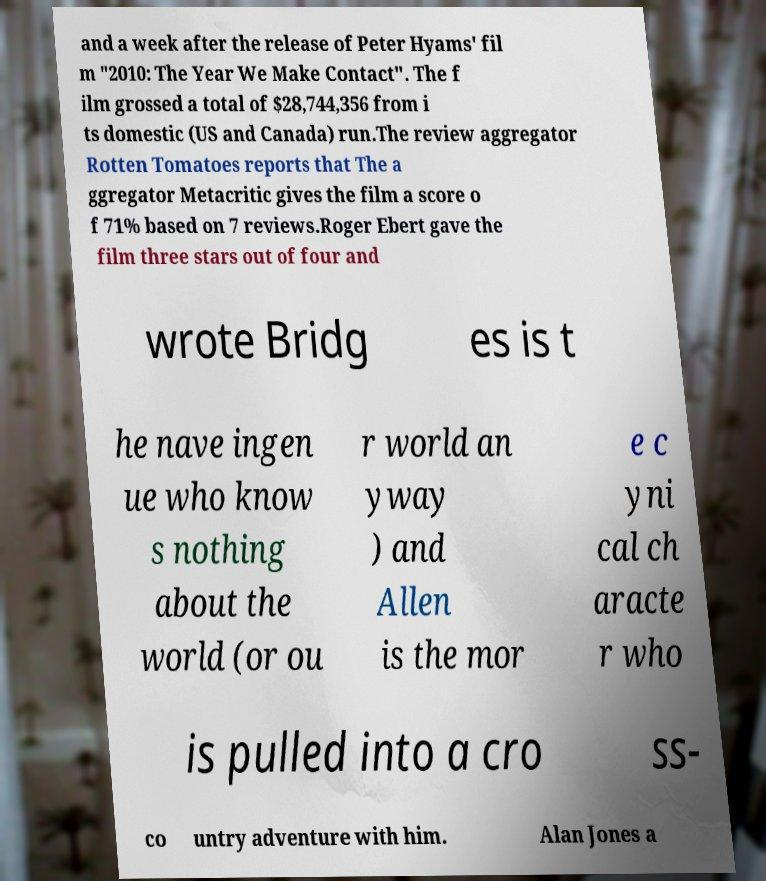What messages or text are displayed in this image? I need them in a readable, typed format. and a week after the release of Peter Hyams' fil m "2010: The Year We Make Contact". The f ilm grossed a total of $28,744,356 from i ts domestic (US and Canada) run.The review aggregator Rotten Tomatoes reports that The a ggregator Metacritic gives the film a score o f 71% based on 7 reviews.Roger Ebert gave the film three stars out of four and wrote Bridg es is t he nave ingen ue who know s nothing about the world (or ou r world an yway ) and Allen is the mor e c yni cal ch aracte r who is pulled into a cro ss- co untry adventure with him. Alan Jones a 